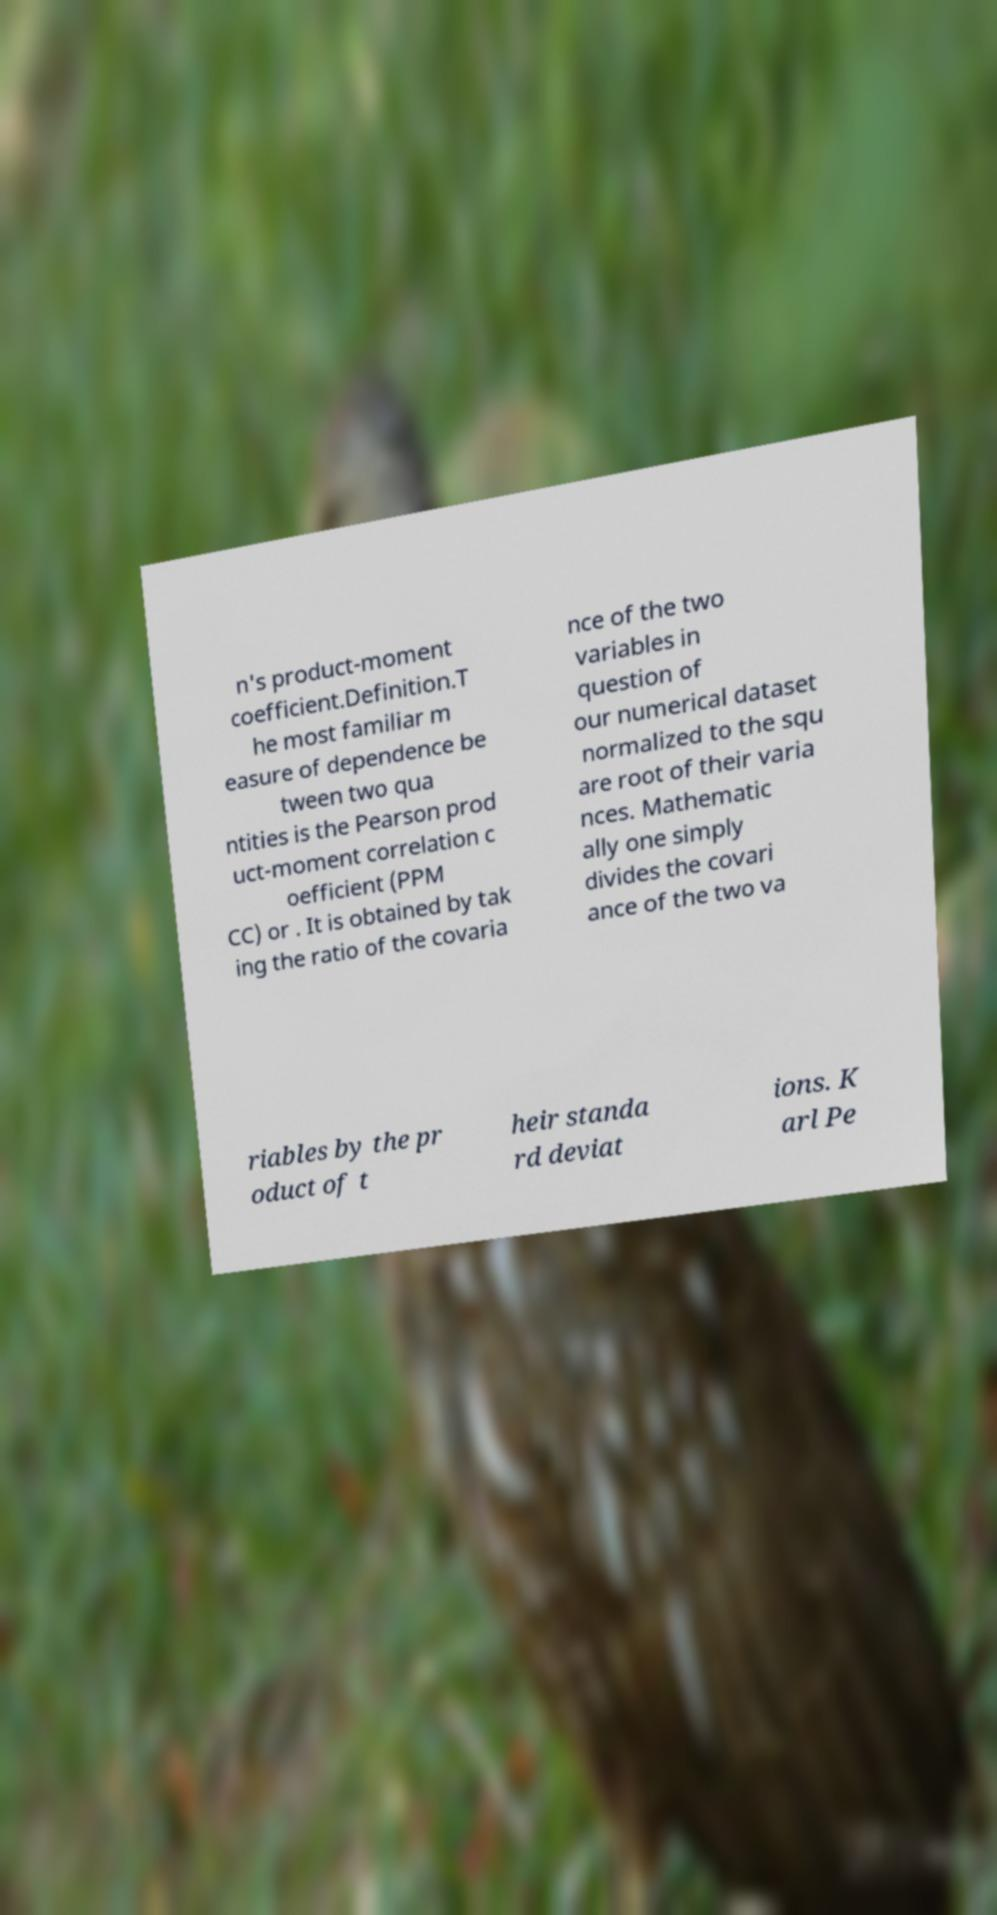Could you assist in decoding the text presented in this image and type it out clearly? n's product-moment coefficient.Definition.T he most familiar m easure of dependence be tween two qua ntities is the Pearson prod uct-moment correlation c oefficient (PPM CC) or . It is obtained by tak ing the ratio of the covaria nce of the two variables in question of our numerical dataset normalized to the squ are root of their varia nces. Mathematic ally one simply divides the covari ance of the two va riables by the pr oduct of t heir standa rd deviat ions. K arl Pe 